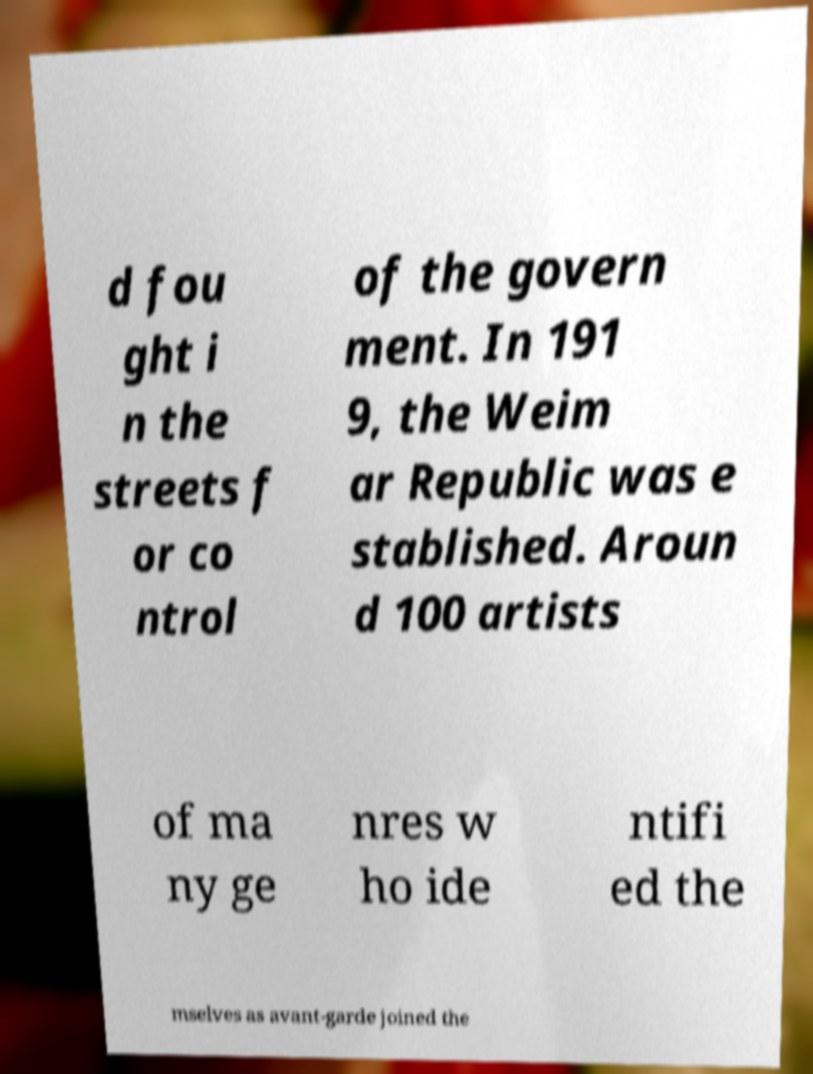Could you assist in decoding the text presented in this image and type it out clearly? d fou ght i n the streets f or co ntrol of the govern ment. In 191 9, the Weim ar Republic was e stablished. Aroun d 100 artists of ma ny ge nres w ho ide ntifi ed the mselves as avant-garde joined the 